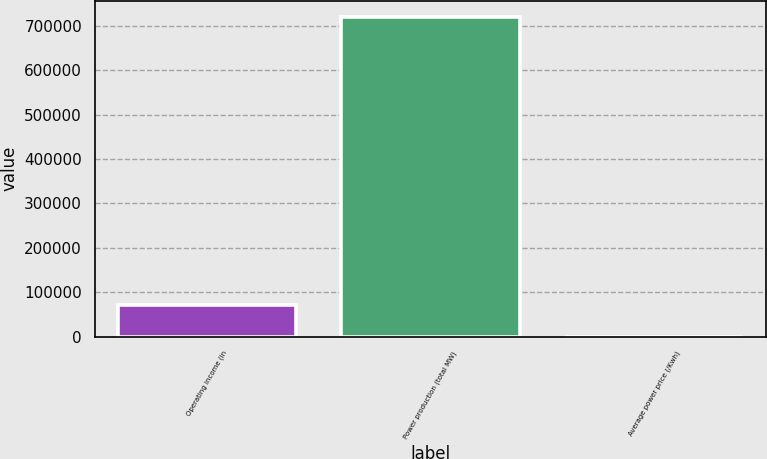Convert chart. <chart><loc_0><loc_0><loc_500><loc_500><bar_chart><fcel>Operating income (in<fcel>Power production (total MW)<fcel>Average power price (/Kwh)<nl><fcel>72030.1<fcel>720300<fcel>0.08<nl></chart> 